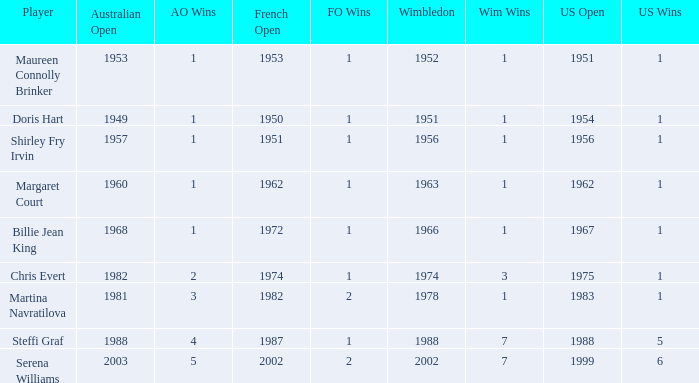When did Shirley Fry Irvin win the US Open? 1956.0. 